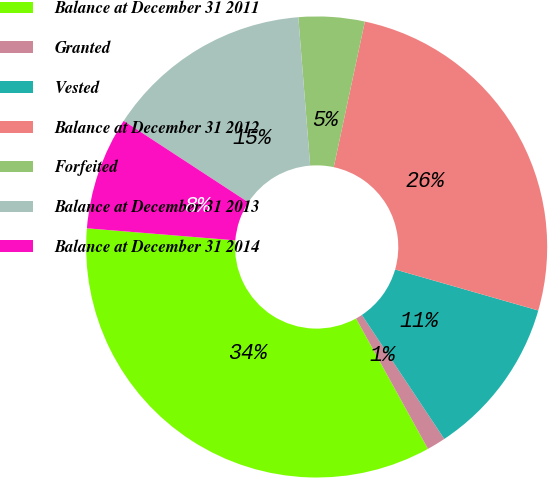Convert chart to OTSL. <chart><loc_0><loc_0><loc_500><loc_500><pie_chart><fcel>Balance at December 31 2011<fcel>Granted<fcel>Vested<fcel>Balance at December 31 2012<fcel>Forfeited<fcel>Balance at December 31 2013<fcel>Balance at December 31 2014<nl><fcel>34.31%<fcel>1.32%<fcel>11.22%<fcel>26.09%<fcel>4.62%<fcel>14.52%<fcel>7.92%<nl></chart> 